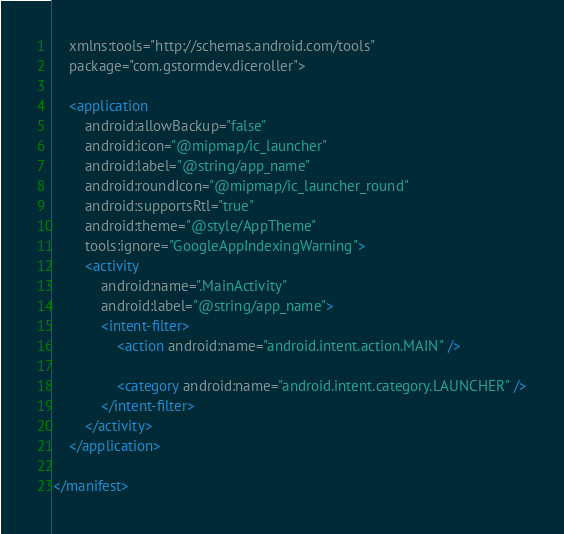<code> <loc_0><loc_0><loc_500><loc_500><_XML_>    xmlns:tools="http://schemas.android.com/tools"
    package="com.gstormdev.diceroller">

    <application
        android:allowBackup="false"
        android:icon="@mipmap/ic_launcher"
        android:label="@string/app_name"
        android:roundIcon="@mipmap/ic_launcher_round"
        android:supportsRtl="true"
        android:theme="@style/AppTheme"
        tools:ignore="GoogleAppIndexingWarning">
        <activity
            android:name=".MainActivity"
            android:label="@string/app_name">
            <intent-filter>
                <action android:name="android.intent.action.MAIN" />

                <category android:name="android.intent.category.LAUNCHER" />
            </intent-filter>
        </activity>
    </application>

</manifest></code> 